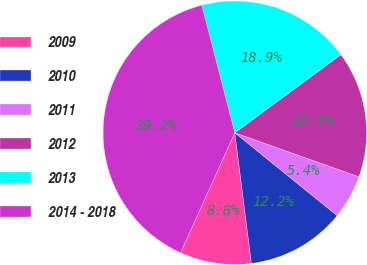Convert chart. <chart><loc_0><loc_0><loc_500><loc_500><pie_chart><fcel>2009<fcel>2010<fcel>2011<fcel>2012<fcel>2013<fcel>2014 - 2018<nl><fcel>8.78%<fcel>12.16%<fcel>5.4%<fcel>15.54%<fcel>18.92%<fcel>39.21%<nl></chart> 